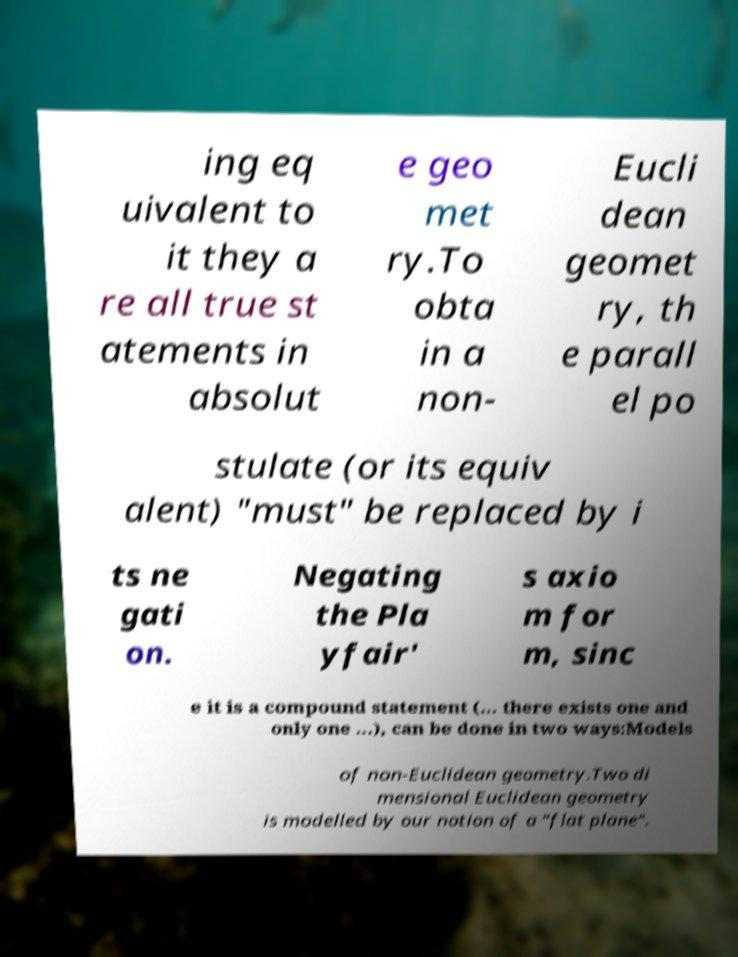Could you extract and type out the text from this image? ing eq uivalent to it they a re all true st atements in absolut e geo met ry.To obta in a non- Eucli dean geomet ry, th e parall el po stulate (or its equiv alent) "must" be replaced by i ts ne gati on. Negating the Pla yfair' s axio m for m, sinc e it is a compound statement (... there exists one and only one ...), can be done in two ways:Models of non-Euclidean geometry.Two di mensional Euclidean geometry is modelled by our notion of a "flat plane". 